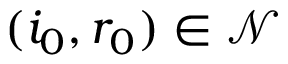<formula> <loc_0><loc_0><loc_500><loc_500>( i _ { 0 } , r _ { 0 } ) \in \mathcal { N }</formula> 